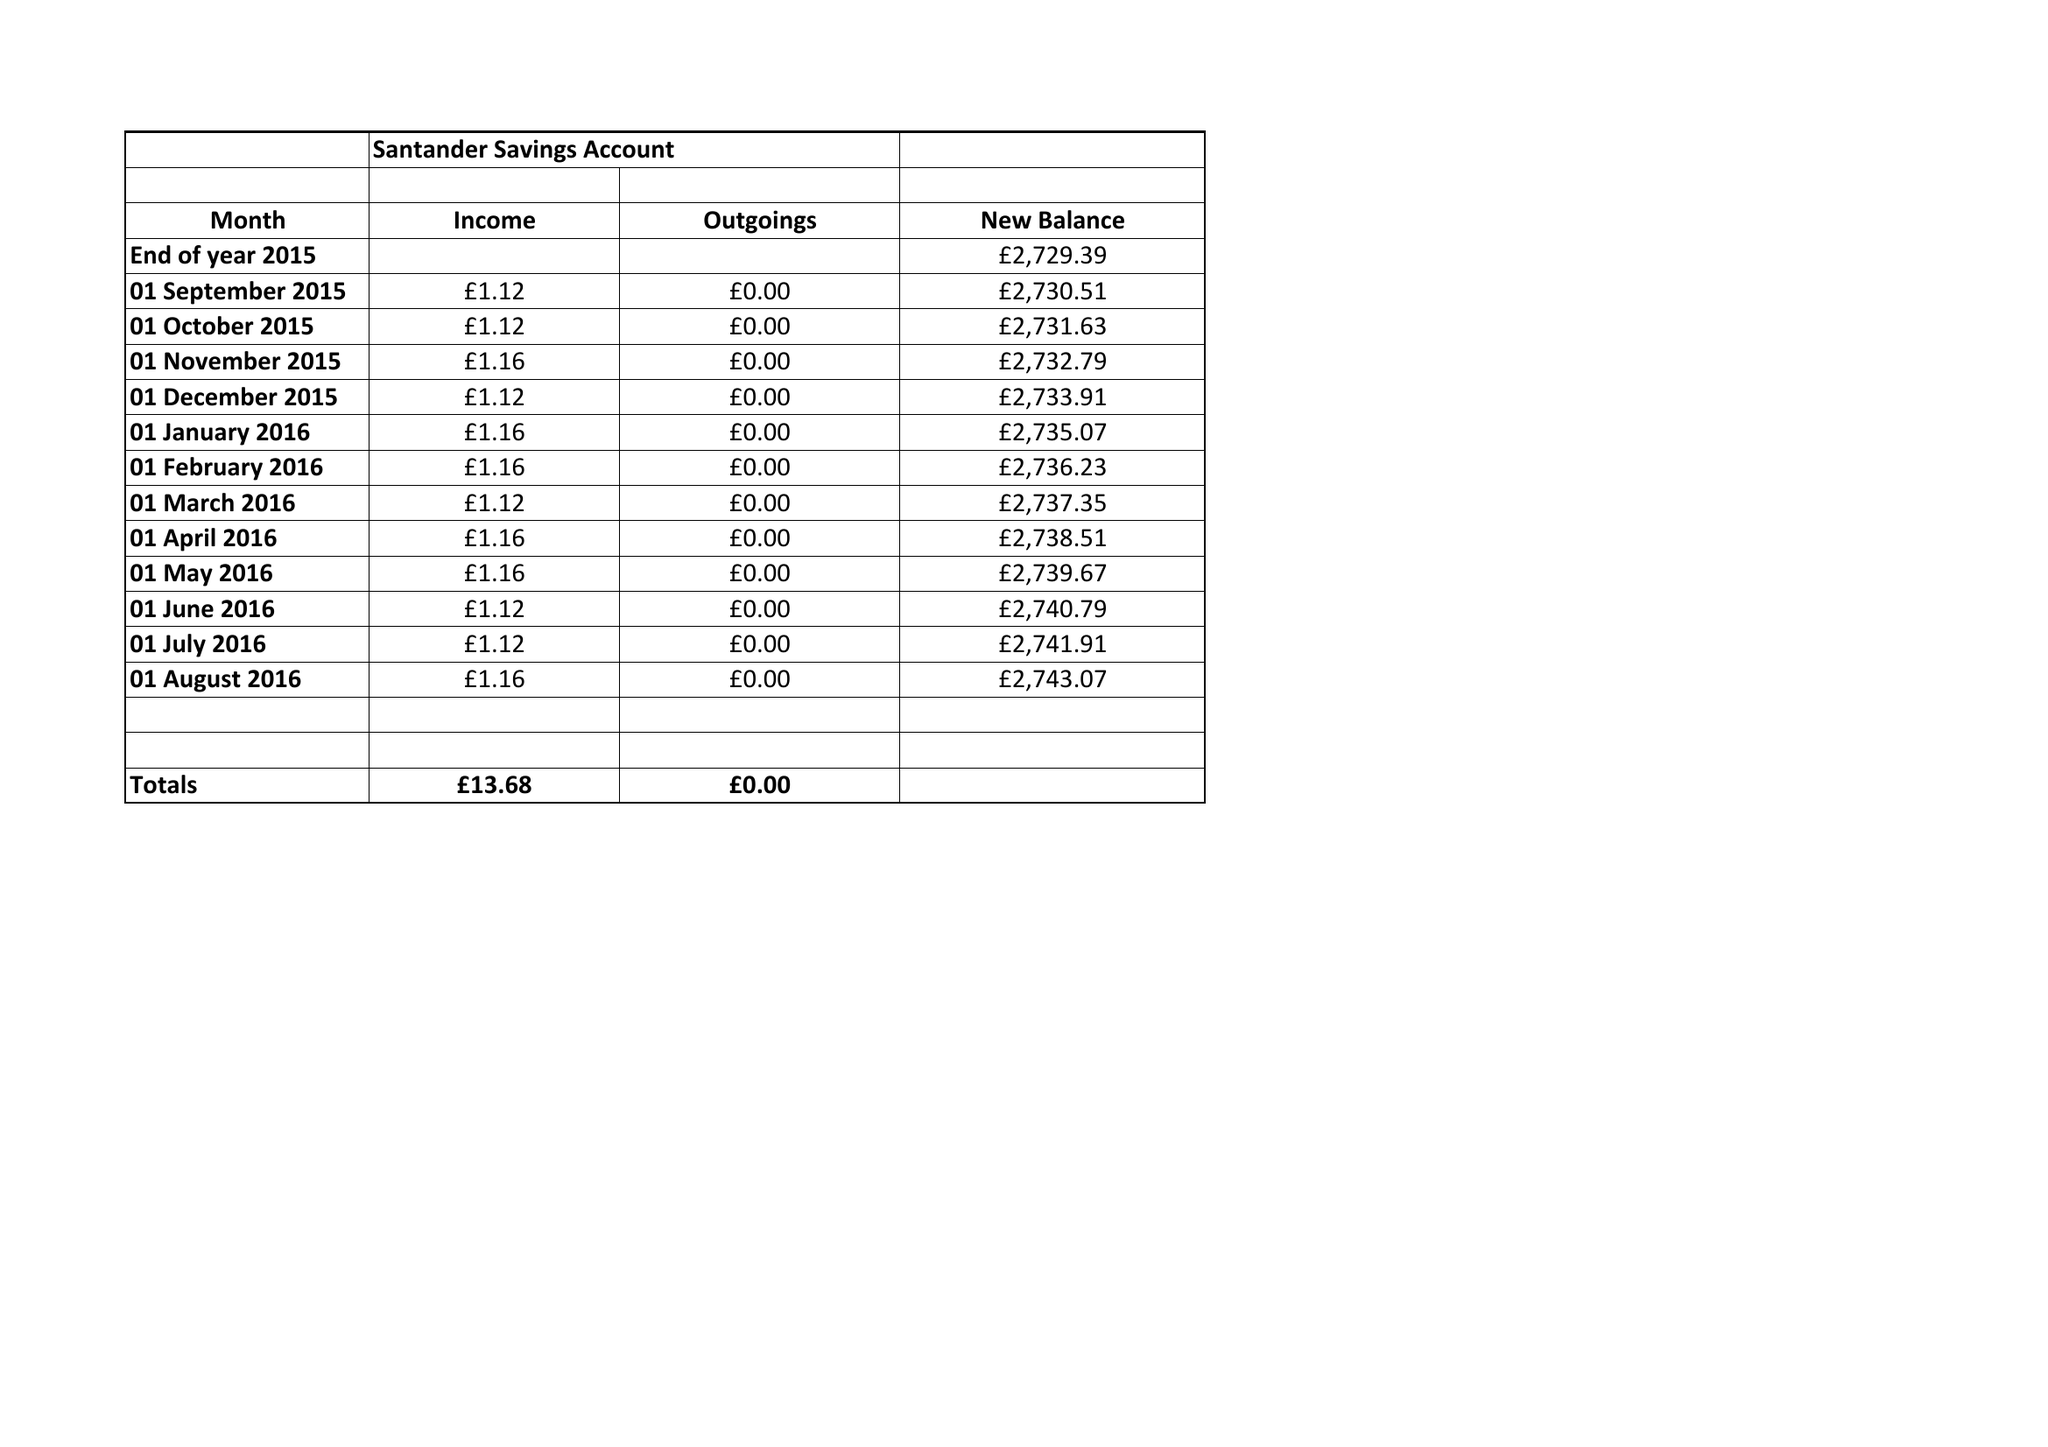What is the value for the charity_name?
Answer the question using a single word or phrase. Great Haywood Under Fives 